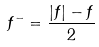Convert formula to latex. <formula><loc_0><loc_0><loc_500><loc_500>f ^ { - } = \frac { | f | - f } { 2 }</formula> 